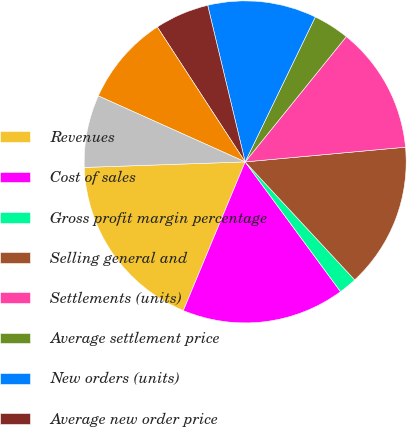Convert chart. <chart><loc_0><loc_0><loc_500><loc_500><pie_chart><fcel>Revenues<fcel>Cost of sales<fcel>Gross profit margin percentage<fcel>Selling general and<fcel>Settlements (units)<fcel>Average settlement price<fcel>New orders (units)<fcel>Average new order price<fcel>Backlog (units)<fcel>Average backlog price<nl><fcel>18.18%<fcel>16.36%<fcel>1.82%<fcel>14.55%<fcel>12.73%<fcel>3.64%<fcel>10.91%<fcel>5.45%<fcel>9.09%<fcel>7.27%<nl></chart> 